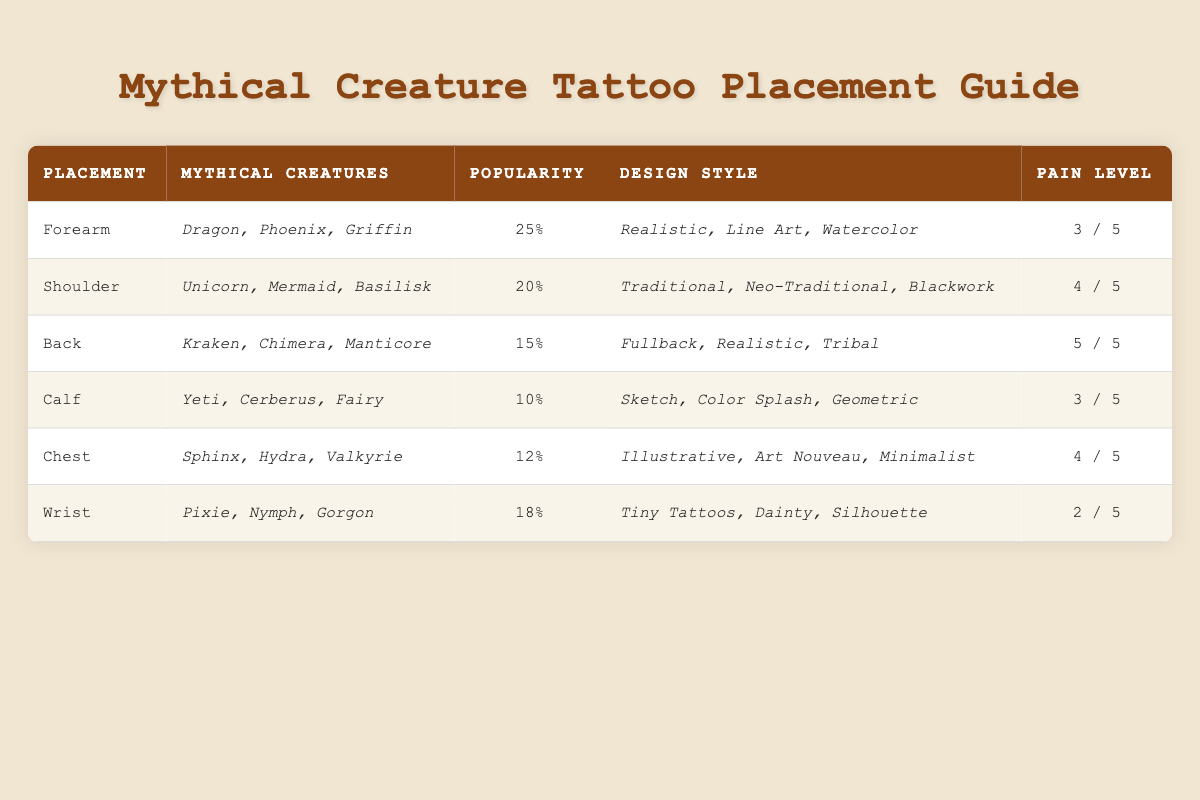What is the placement with the highest popularity percentage? The placement with the highest popularity percentage is "Forearm," which has a popularity percentage of 25.
Answer: Forearm Which mythical creature is associated with the "Shoulder" placement? The mythical creatures associated with the "Shoulder" placement are "Unicorn," "Mermaid," and "Basilisk."
Answer: Unicorn, Mermaid, Basilisk How many placements have a pain level of 4? There are two placements with a pain level of 4: "Shoulder" and "Chest."
Answer: 2 What is the average popularity percentage of the tattoo placements? The total popularity percentages are 25 + 20 + 15 + 10 + 12 + 18 = 110. There are 6 placements, so the average popularity percentage is 110 / 6 = 18.33.
Answer: 18.33 Is the "Wrist" placement associated with higher pain than the "Calf" placement? The "Wrist" placement has a pain level of 2, while the "Calf" placement has a pain level of 3, so the statement is false.
Answer: No Which placement has the lowest popularity and what mythical creatures are associated with it? The placement with the lowest popularity is "Calf," which has a popularity percentage of 10. It is associated with the mythical creatures "Yeti," "Cerberus," and "Fairy."
Answer: Calf, Yeti, Cerberus, Fairy What is the total pain level of all tattoo placements? The total pain levels for each placement are 3 (Forearm) + 4 (Shoulder) + 5 (Back) + 3 (Calf) + 4 (Chest) + 2 (Wrist) = 21.
Answer: 21 Which placement features the design style "Illustrative"? The placement that features the design style "Illustrative" is "Chest."
Answer: Chest How many mythical creatures are associated with the "Back" tattoo placement? There are three mythical creatures associated with the "Back" placement: "Kraken," "Chimera," and "Manticore."
Answer: 3 